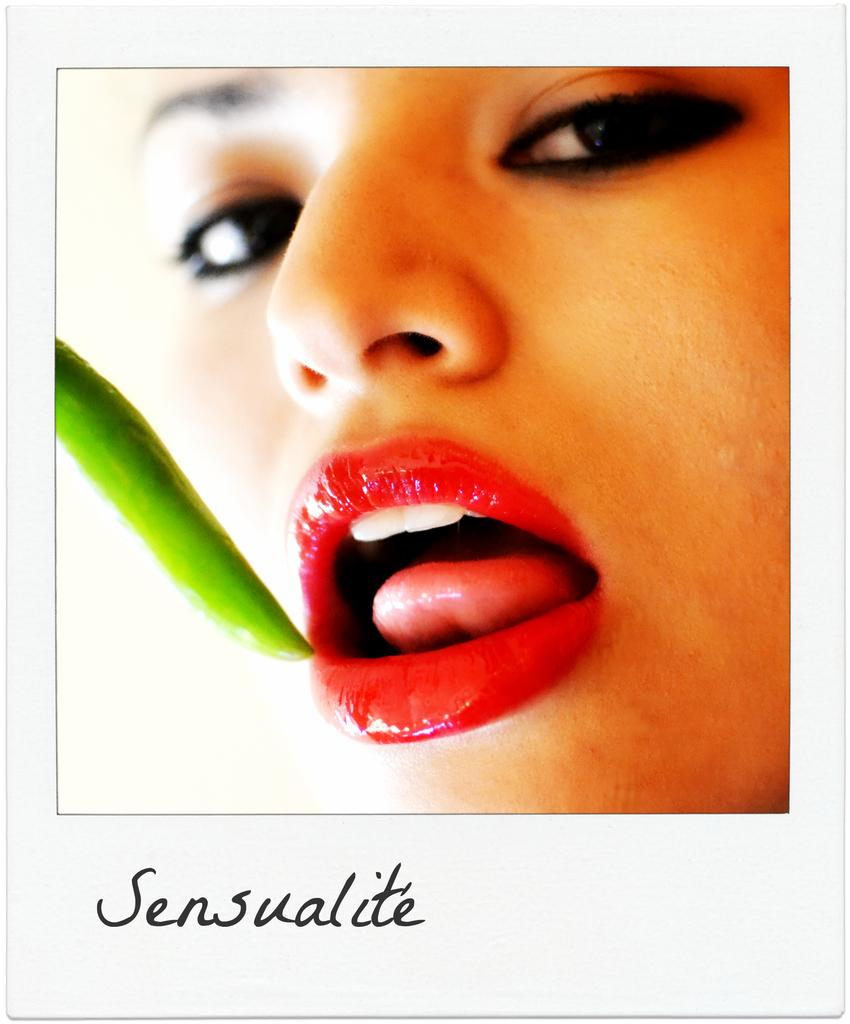What is the main subject of the image? The image contains a photograph. Who or what can be seen in the photograph? There is a woman and a chilly in the photograph. Can you tell me how many streams are visible in the photograph? There are no streams visible in the photograph; it features a woman and a chilly. What type of wood is used to make the chilly in the photograph? The photograph does not provide information about the material used to make the chilly. 